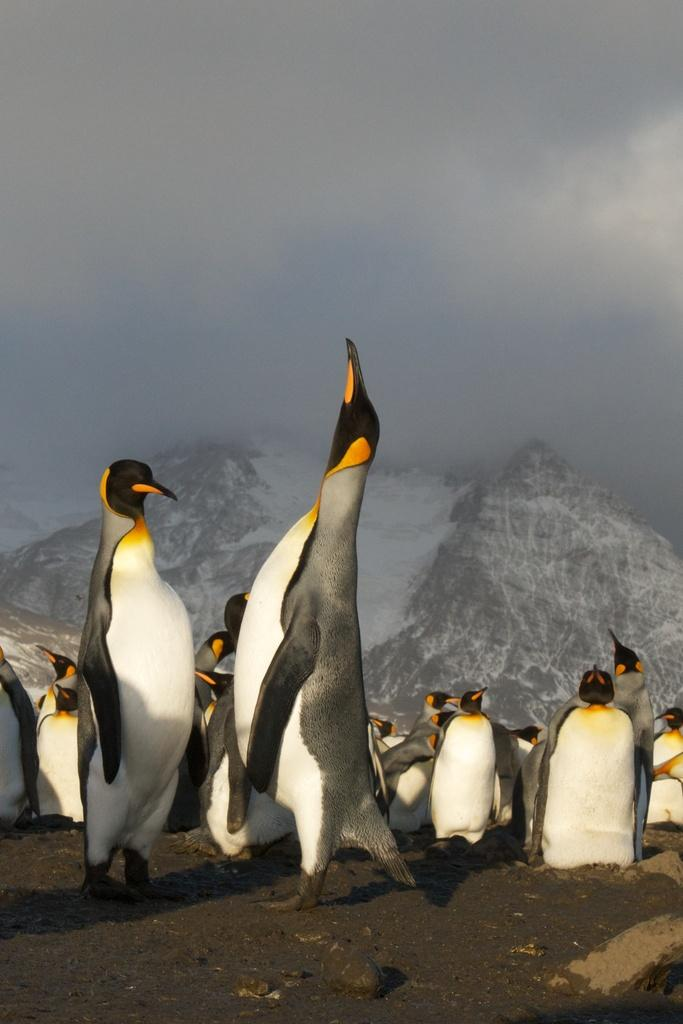What type of animals are present in the image? There are penguins in the image. What type of landscape can be seen in the image? There are snowy mountains in the image. What is visible in the background of the image? The sky is visible in the background of the image. What type of bun is being served to the penguins in the image? There is no bun present in the image; it features penguins and snowy mountains. Can you read the letter that the penguins are holding in the image? There are no penguins holding letters in the image. 